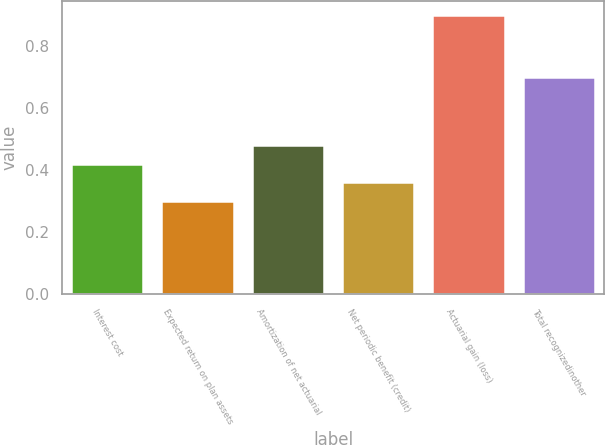Convert chart. <chart><loc_0><loc_0><loc_500><loc_500><bar_chart><fcel>Interest cost<fcel>Expected return on plan assets<fcel>Amortization of net actuarial<fcel>Net periodic benefit (credit)<fcel>Actuarial gain (loss)<fcel>Total recognizedinother<nl><fcel>0.42<fcel>0.3<fcel>0.48<fcel>0.36<fcel>0.9<fcel>0.7<nl></chart> 